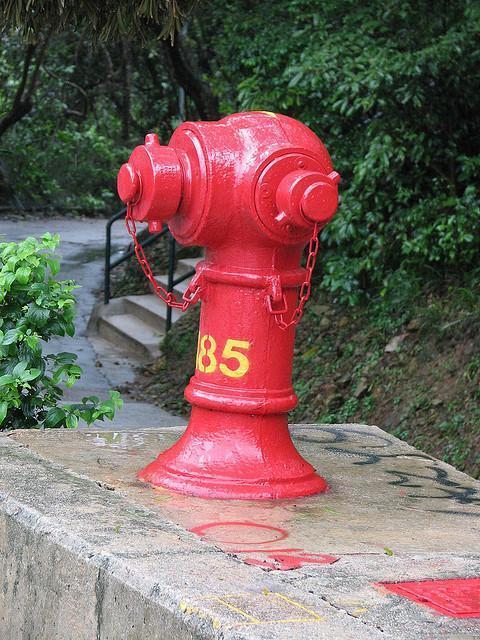How many white cars are there?
Give a very brief answer. 0. 